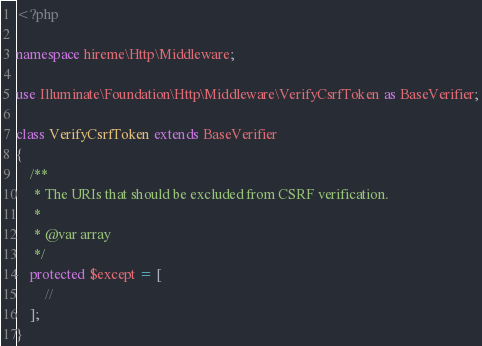<code> <loc_0><loc_0><loc_500><loc_500><_PHP_><?php

namespace hireme\Http\Middleware;

use Illuminate\Foundation\Http\Middleware\VerifyCsrfToken as BaseVerifier;

class VerifyCsrfToken extends BaseVerifier
{
    /**
     * The URIs that should be excluded from CSRF verification.
     *
     * @var array
     */
    protected $except = [
        //
    ];
}
</code> 